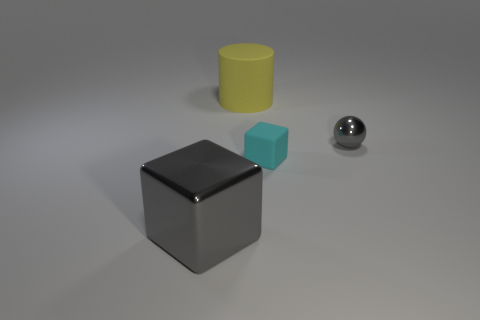Add 3 gray metallic blocks. How many objects exist? 7 Subtract all spheres. How many objects are left? 3 Subtract 1 yellow cylinders. How many objects are left? 3 Subtract all small balls. Subtract all gray things. How many objects are left? 1 Add 4 small gray shiny objects. How many small gray shiny objects are left? 5 Add 2 tiny gray things. How many tiny gray things exist? 3 